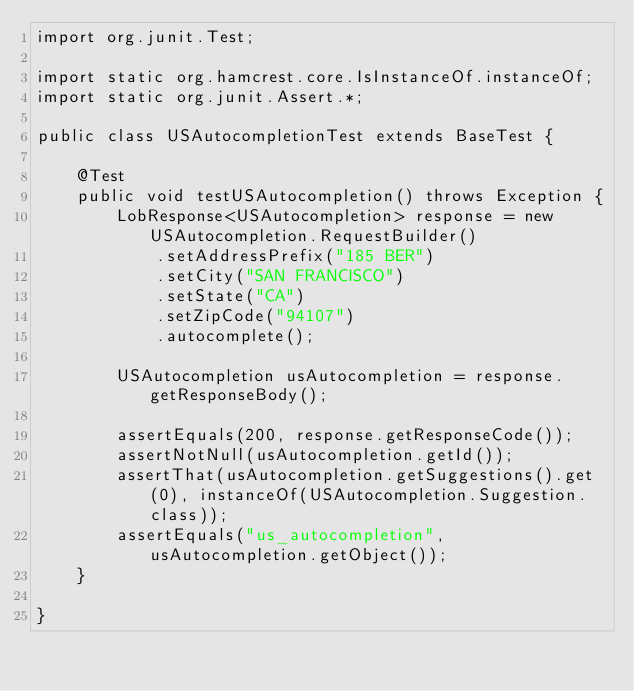<code> <loc_0><loc_0><loc_500><loc_500><_Java_>import org.junit.Test;

import static org.hamcrest.core.IsInstanceOf.instanceOf;
import static org.junit.Assert.*;

public class USAutocompletionTest extends BaseTest {

    @Test
    public void testUSAutocompletion() throws Exception {
        LobResponse<USAutocompletion> response = new USAutocompletion.RequestBuilder()
            .setAddressPrefix("185 BER")
            .setCity("SAN FRANCISCO")
            .setState("CA")
            .setZipCode("94107")
            .autocomplete();

        USAutocompletion usAutocompletion = response.getResponseBody();

        assertEquals(200, response.getResponseCode());
        assertNotNull(usAutocompletion.getId());
        assertThat(usAutocompletion.getSuggestions().get(0), instanceOf(USAutocompletion.Suggestion.class));
        assertEquals("us_autocompletion", usAutocompletion.getObject());
    }

}
</code> 